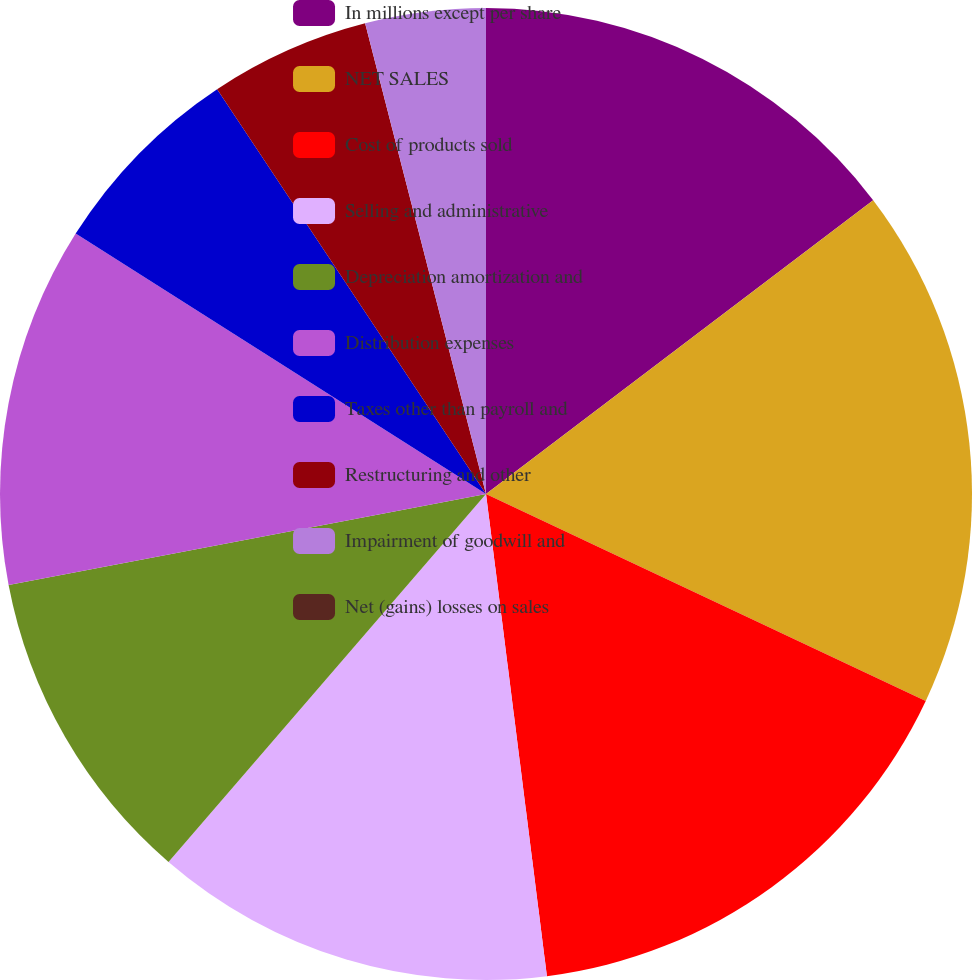Convert chart. <chart><loc_0><loc_0><loc_500><loc_500><pie_chart><fcel>In millions except per share<fcel>NET SALES<fcel>Cost of products sold<fcel>Selling and administrative<fcel>Depreciation amortization and<fcel>Distribution expenses<fcel>Taxes other than payroll and<fcel>Restructuring and other<fcel>Impairment of goodwill and<fcel>Net (gains) losses on sales<nl><fcel>14.67%<fcel>17.33%<fcel>16.0%<fcel>13.33%<fcel>10.67%<fcel>12.0%<fcel>6.67%<fcel>5.33%<fcel>4.0%<fcel>0.0%<nl></chart> 